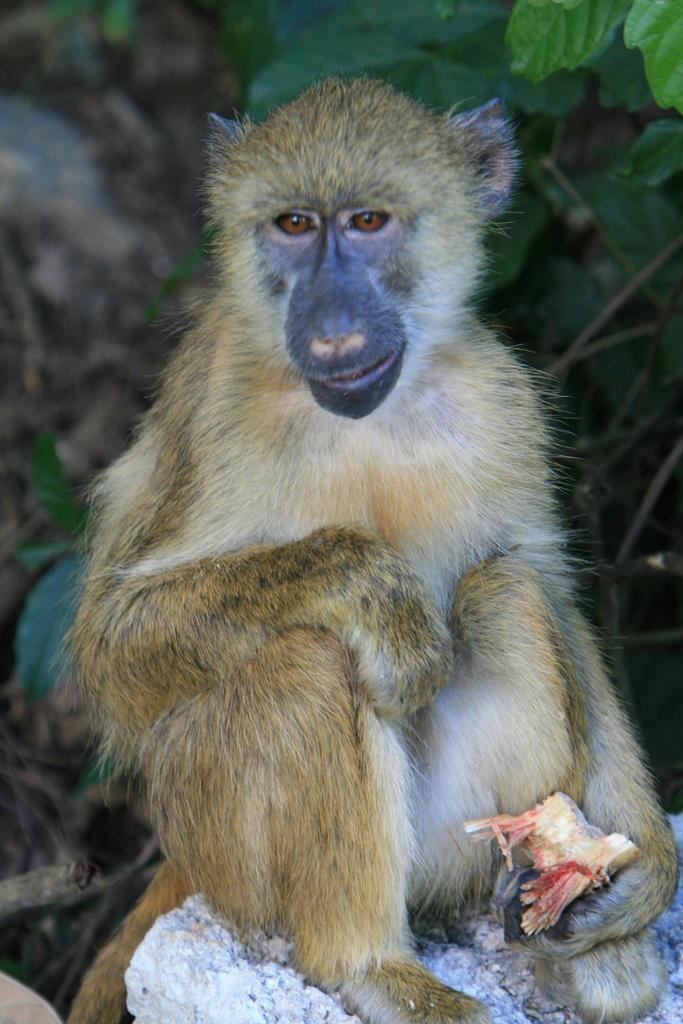What animal is present in the image? There is a monkey in the image. What is the monkey holding in its hand? The monkey is holding something in its hand, but the specific object cannot be determined from the image. Where is the monkey sitting? The monkey is sitting on a stone. What can be seen behind the monkey? There is a tree behind the monkey. What type of appliance can be seen in the image? There is no appliance present in the image. What part of the monkey's body is missing in the image? The monkey is fully visible in the image, and no part of its body is missing. 